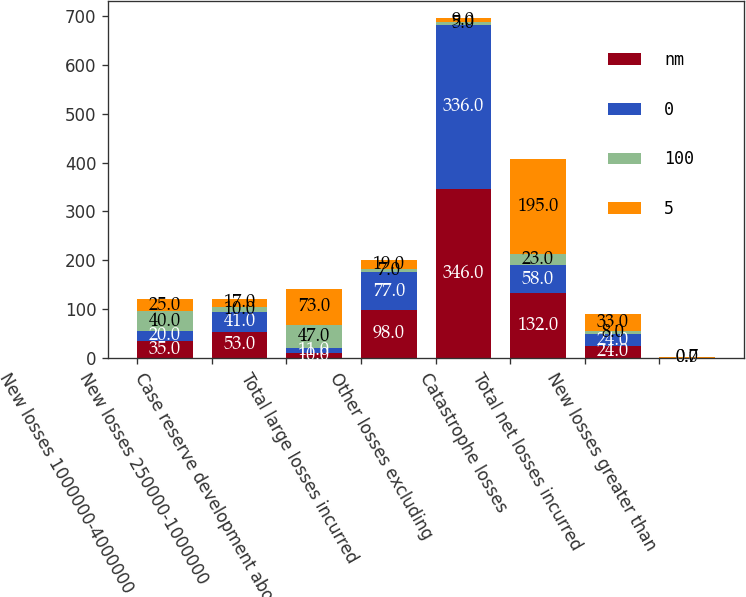Convert chart to OTSL. <chart><loc_0><loc_0><loc_500><loc_500><stacked_bar_chart><ecel><fcel>New losses 1000000-4000000<fcel>New losses 250000-1000000<fcel>Case reserve development above<fcel>Total large losses incurred<fcel>Other losses excluding<fcel>Catastrophe losses<fcel>Total net losses incurred<fcel>New losses greater than<nl><fcel>nm<fcel>35<fcel>53<fcel>10<fcel>98<fcel>346<fcel>132<fcel>24<fcel>0<nl><fcel>0<fcel>20<fcel>41<fcel>11<fcel>77<fcel>336<fcel>58<fcel>24<fcel>0.7<nl><fcel>100<fcel>40<fcel>10<fcel>47<fcel>7<fcel>5<fcel>23<fcel>8<fcel>0<nl><fcel>5<fcel>25<fcel>17<fcel>73<fcel>19<fcel>9<fcel>195<fcel>33<fcel>0.7<nl></chart> 